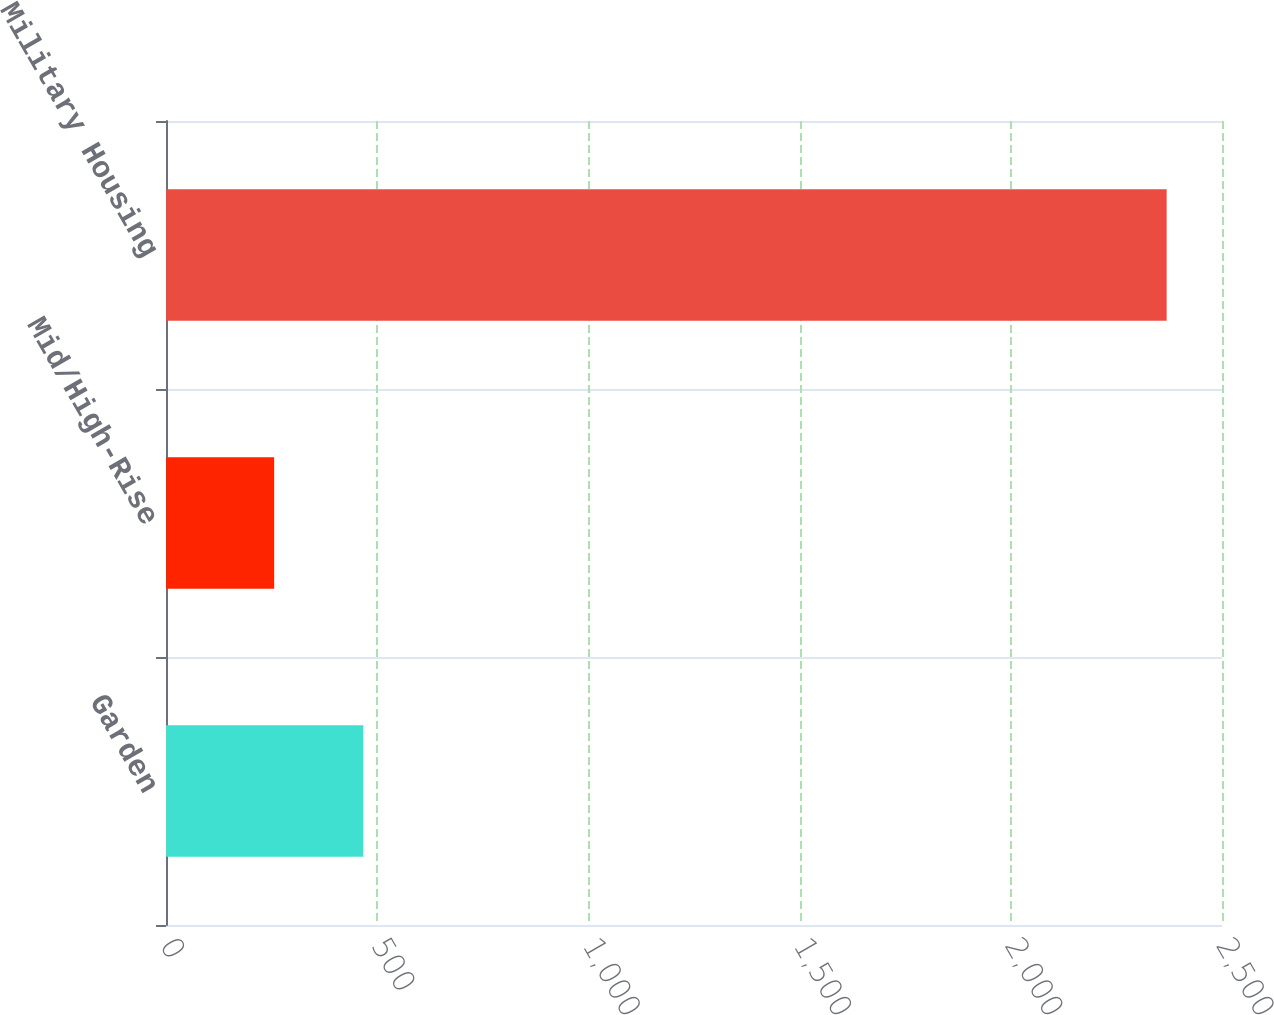Convert chart to OTSL. <chart><loc_0><loc_0><loc_500><loc_500><bar_chart><fcel>Garden<fcel>Mid/High-Rise<fcel>Military Housing<nl><fcel>467.3<fcel>256<fcel>2369<nl></chart> 